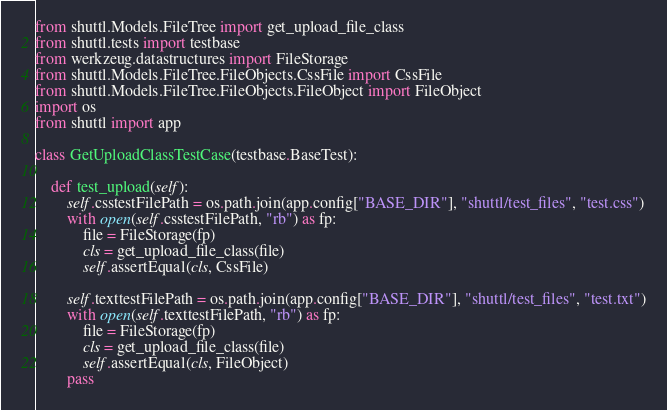Convert code to text. <code><loc_0><loc_0><loc_500><loc_500><_Python_>from shuttl.Models.FileTree import get_upload_file_class
from shuttl.tests import testbase
from werkzeug.datastructures import FileStorage
from shuttl.Models.FileTree.FileObjects.CssFile import CssFile
from shuttl.Models.FileTree.FileObjects.FileObject import FileObject
import os
from shuttl import app

class GetUploadClassTestCase(testbase.BaseTest):

    def test_upload(self):
        self.csstestFilePath = os.path.join(app.config["BASE_DIR"], "shuttl/test_files", "test.css")
        with open(self.csstestFilePath, "rb") as fp:
            file = FileStorage(fp)
            cls = get_upload_file_class(file)
            self.assertEqual(cls, CssFile)

        self.texttestFilePath = os.path.join(app.config["BASE_DIR"], "shuttl/test_files", "test.txt")
        with open(self.texttestFilePath, "rb") as fp:
            file = FileStorage(fp)
            cls = get_upload_file_class(file)
            self.assertEqual(cls, FileObject)
        pass</code> 